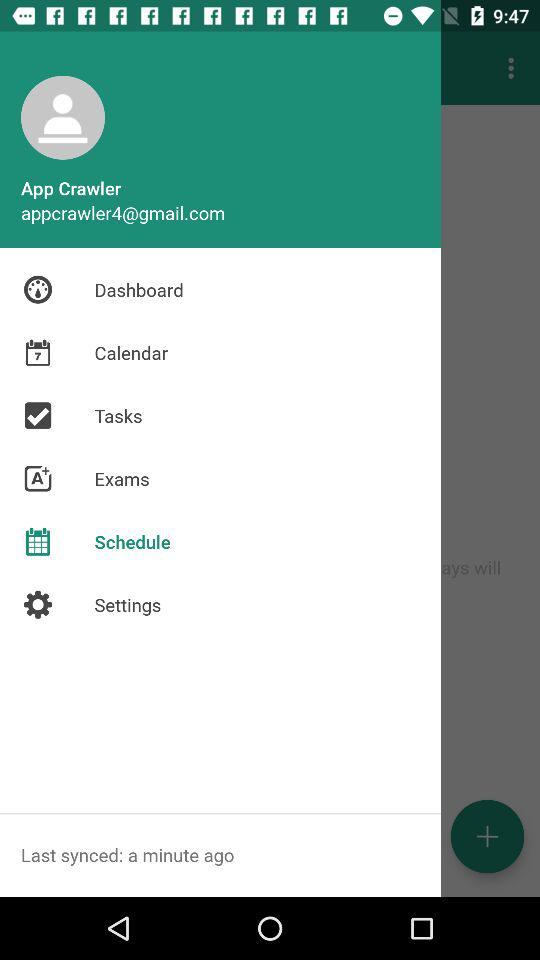Which item is selected? The selected item is "Schedule". 